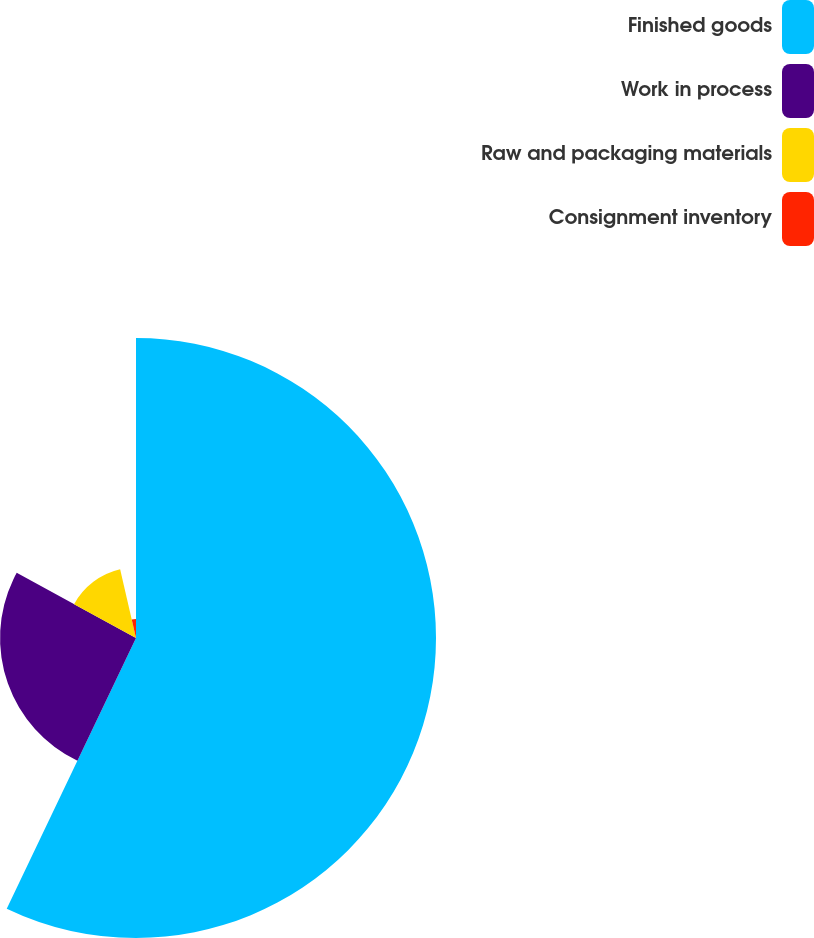Convert chart to OTSL. <chart><loc_0><loc_0><loc_500><loc_500><pie_chart><fcel>Finished goods<fcel>Work in process<fcel>Raw and packaging materials<fcel>Consignment inventory<nl><fcel>57.09%<fcel>25.87%<fcel>13.43%<fcel>3.61%<nl></chart> 